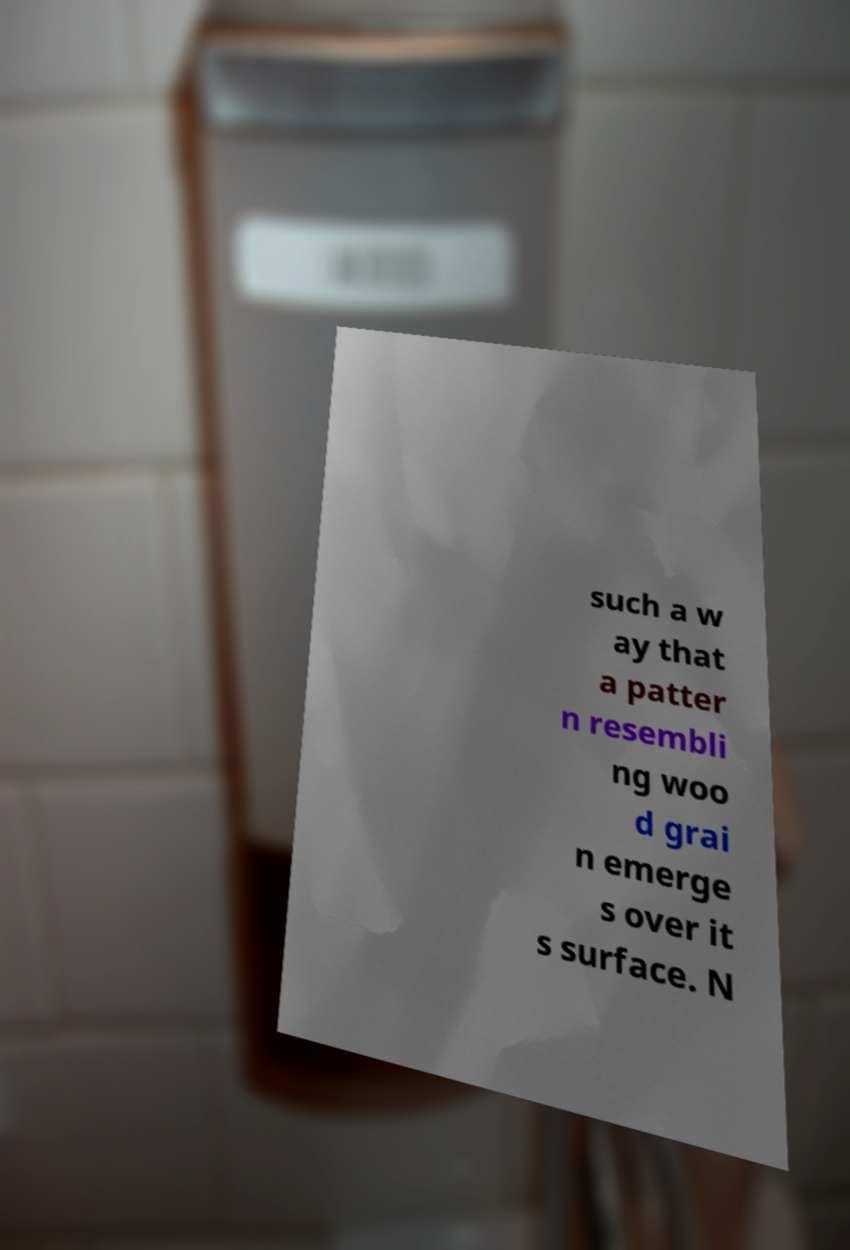Can you accurately transcribe the text from the provided image for me? such a w ay that a patter n resembli ng woo d grai n emerge s over it s surface. N 